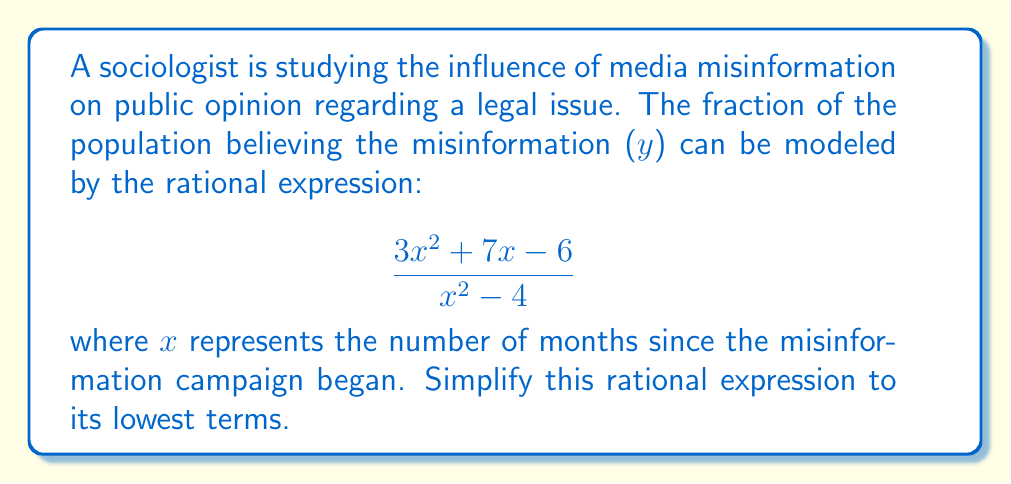Teach me how to tackle this problem. To simplify this rational expression, we need to factor both the numerator and denominator and then cancel any common factors:

1) Factor the numerator:
   $3x^2 + 7x - 6 = (3x-2)(x+3)$

2) Factor the denominator:
   $x^2 - 4 = (x+2)(x-2)$

3) Rewrite the expression with factored numerator and denominator:
   $$\frac{(3x-2)(x+3)}{(x+2)(x-2)}$$

4) There are no common factors between the numerator and denominator, so this is the simplest form of the rational expression.

This simplified form represents the proportion of the population influenced by media misinformation over time, with $x$ being the number of months since the campaign began. The expression is undefined when $x = 2$ or $x = -2$, which could represent critical points in the misinformation campaign's timeline.
Answer: $$\frac{(3x-2)(x+3)}{(x+2)(x-2)}$$ 